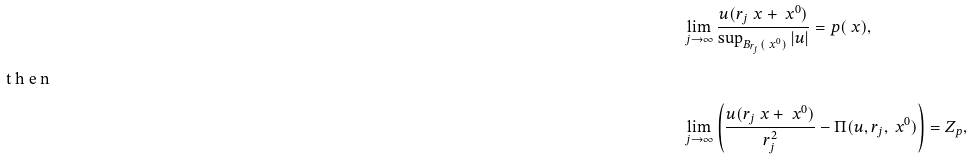Convert formula to latex. <formula><loc_0><loc_0><loc_500><loc_500>& \lim _ { j \to \infty } \frac { u ( r _ { j } \ x + \ x ^ { 0 } ) } { \sup _ { B _ { r _ { j } } ( \ x ^ { 0 } ) } | u | } = p ( \ x ) , \intertext { t h e n } & \lim _ { j \to \infty } \left ( \frac { u ( r _ { j } \ x + \ x ^ { 0 } ) } { r _ { j } ^ { 2 } } - \Pi ( u , r _ { j } , \ x ^ { 0 } ) \right ) = Z _ { p } ,</formula> 